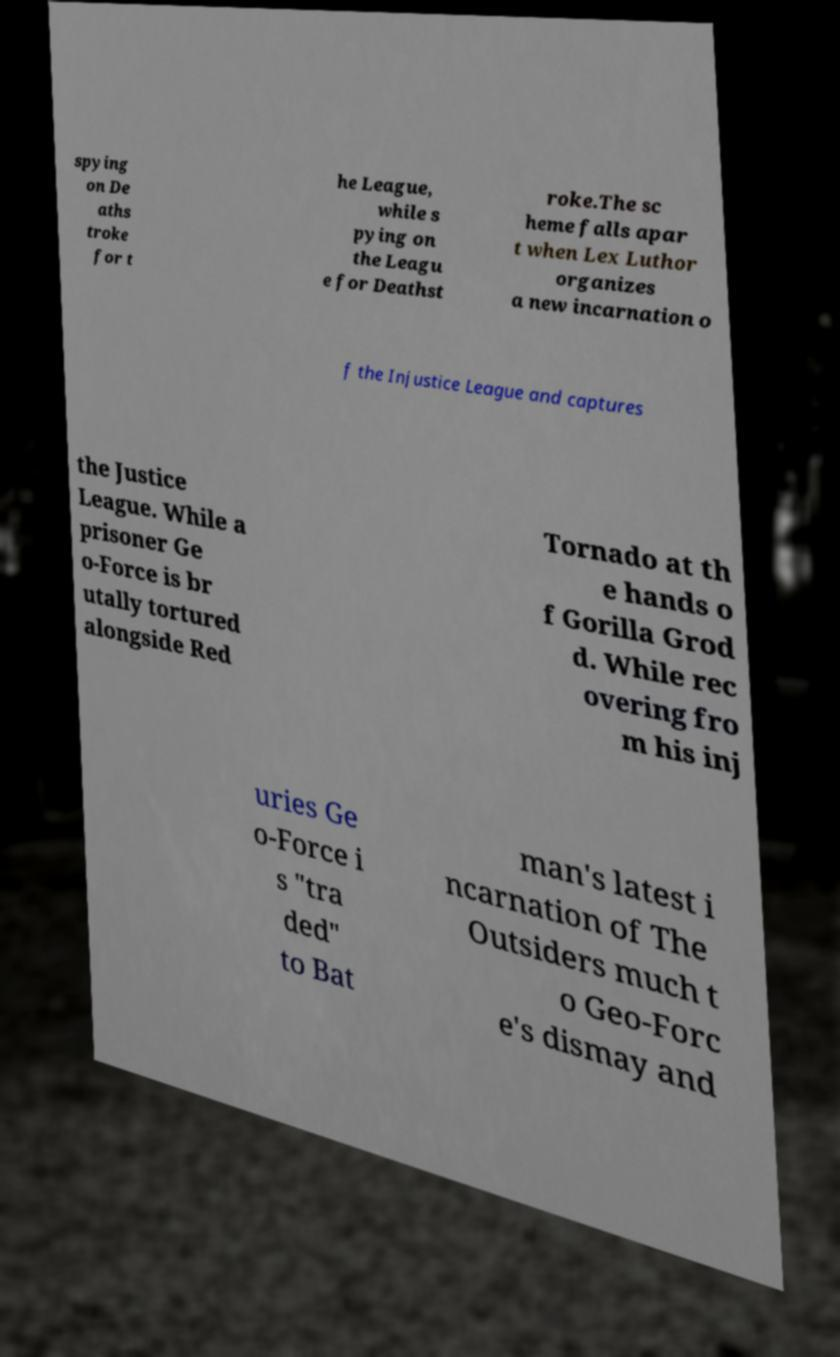Could you extract and type out the text from this image? spying on De aths troke for t he League, while s pying on the Leagu e for Deathst roke.The sc heme falls apar t when Lex Luthor organizes a new incarnation o f the Injustice League and captures the Justice League. While a prisoner Ge o-Force is br utally tortured alongside Red Tornado at th e hands o f Gorilla Grod d. While rec overing fro m his inj uries Ge o-Force i s "tra ded" to Bat man's latest i ncarnation of The Outsiders much t o Geo-Forc e's dismay and 